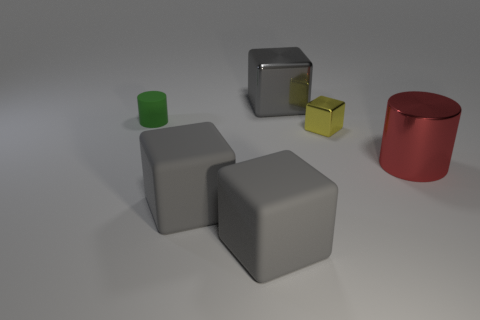Subtract all gray cubes. How many were subtracted if there are2gray cubes left? 1 Subtract all purple cylinders. How many gray cubes are left? 3 Subtract all yellow blocks. Subtract all cyan cylinders. How many blocks are left? 3 Add 1 big matte objects. How many objects exist? 7 Subtract all blocks. How many objects are left? 2 Add 3 tiny cubes. How many tiny cubes are left? 4 Add 6 big gray rubber blocks. How many big gray rubber blocks exist? 8 Subtract 0 red cubes. How many objects are left? 6 Subtract all large purple cylinders. Subtract all gray cubes. How many objects are left? 3 